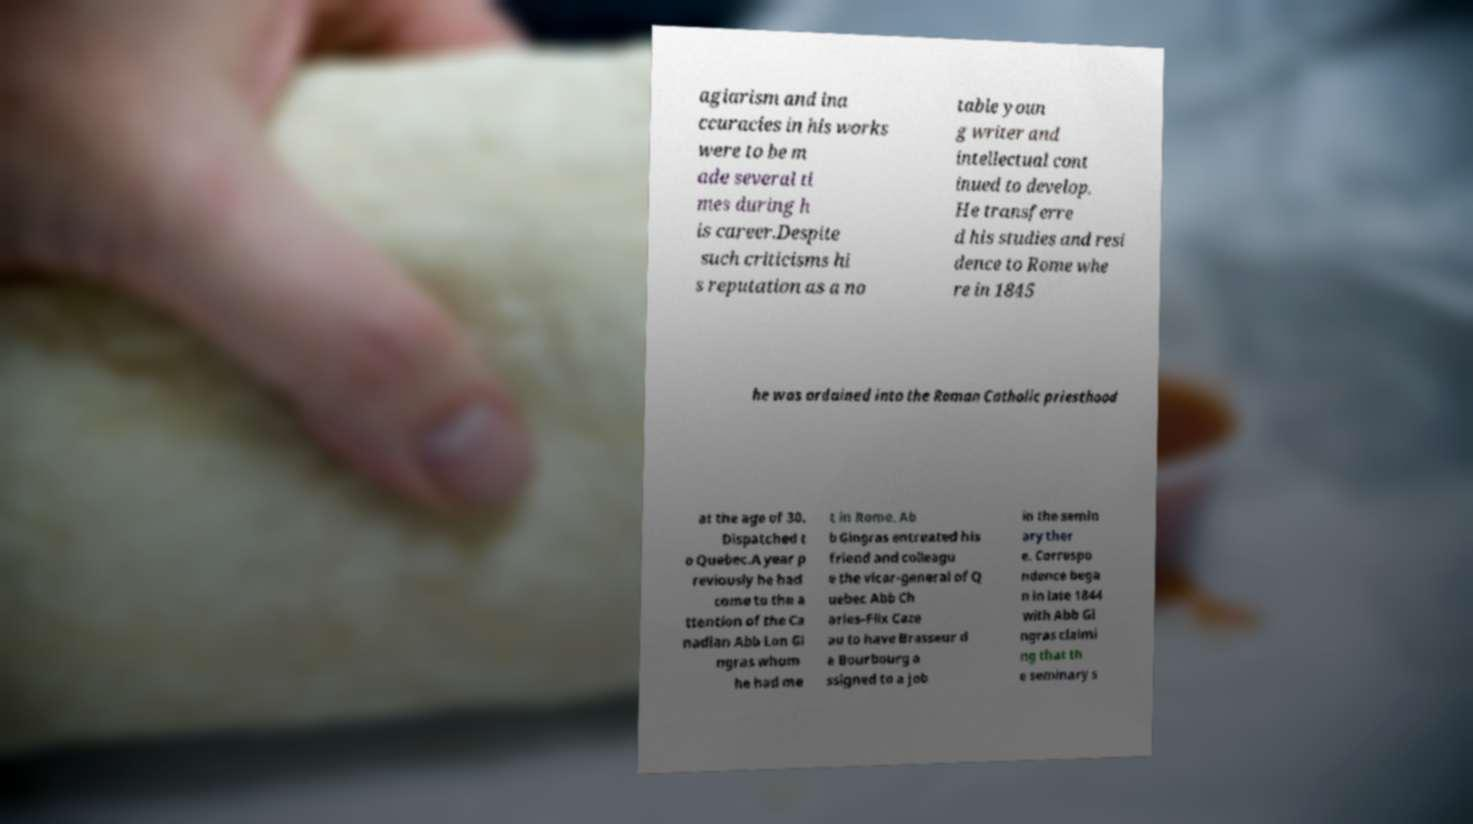Please identify and transcribe the text found in this image. agiarism and ina ccuracies in his works were to be m ade several ti mes during h is career.Despite such criticisms hi s reputation as a no table youn g writer and intellectual cont inued to develop. He transferre d his studies and resi dence to Rome whe re in 1845 he was ordained into the Roman Catholic priesthood at the age of 30. Dispatched t o Quebec.A year p reviously he had come to the a ttention of the Ca nadian Abb Lon Gi ngras whom he had me t in Rome. Ab b Gingras entreated his friend and colleagu e the vicar-general of Q uebec Abb Ch arles-Flix Caze au to have Brasseur d e Bourbourg a ssigned to a job in the semin ary ther e. Correspo ndence bega n in late 1844 with Abb Gi ngras claimi ng that th e seminary s 